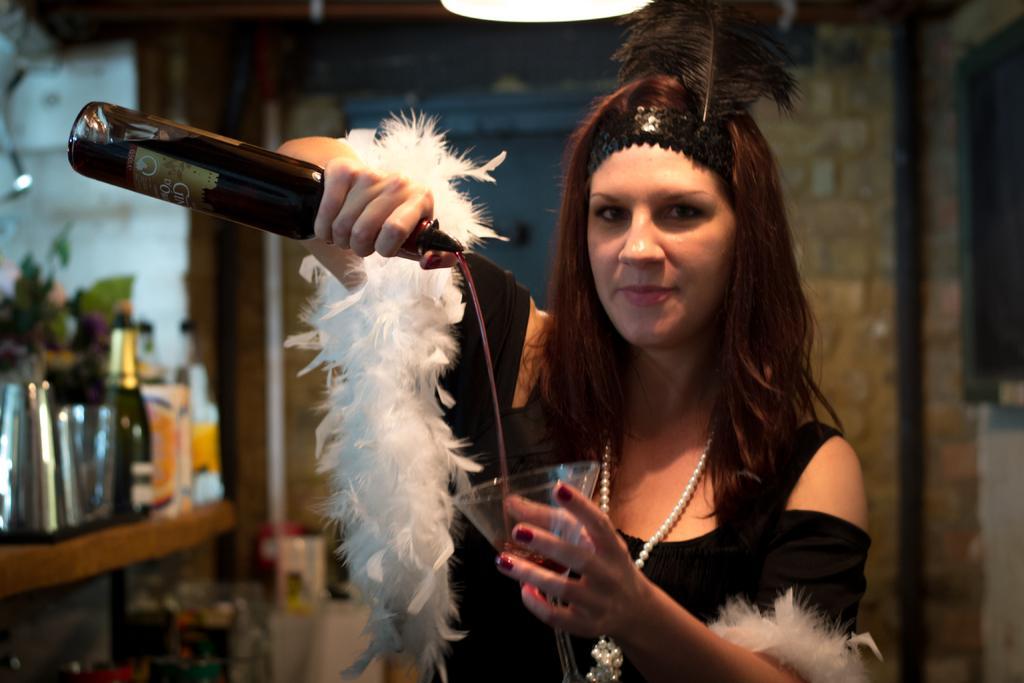Please provide a concise description of this image. In this picture we can see a woman pouring juice into the glass from the bottle. On the background there is a wall. And these are the bottles. 